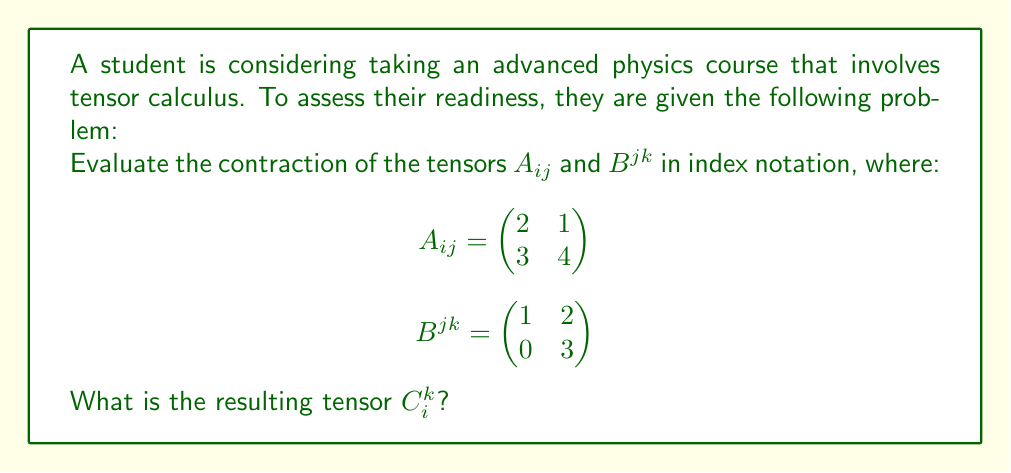Give your solution to this math problem. To evaluate the contraction of tensors $A_{ij}$ and $B^{jk}$, we need to follow these steps:

1) The contraction is performed over the repeated index $j$. The resulting tensor $C_i^k$ will have one lower index $i$ and one upper index $k$.

2) In index notation, the contraction is written as:

   $C_i^k = A_{ij}B^{jk}$

3) This operation is equivalent to matrix multiplication. We multiply each row of $A_{ij}$ with each column of $B^{jk}$.

4) Let's calculate each element of $C_i^k$:

   $C_1^1 = A_{11}B^{11} + A_{12}B^{21} = (2)(1) + (1)(0) = 2$
   
   $C_1^2 = A_{11}B^{12} + A_{12}B^{22} = (2)(2) + (1)(3) = 7$
   
   $C_2^1 = A_{21}B^{11} + A_{22}B^{21} = (3)(1) + (4)(0) = 3$
   
   $C_2^2 = A_{21}B^{12} + A_{22}B^{22} = (3)(2) + (4)(3) = 18$

5) Therefore, the resulting tensor $C_i^k$ is:

   $$C_i^k = \begin{pmatrix}
   2 & 7 \\
   3 & 18
   \end{pmatrix}$$
Answer: $$C_i^k = \begin{pmatrix}
2 & 7 \\
3 & 18
\end{pmatrix}$$ 